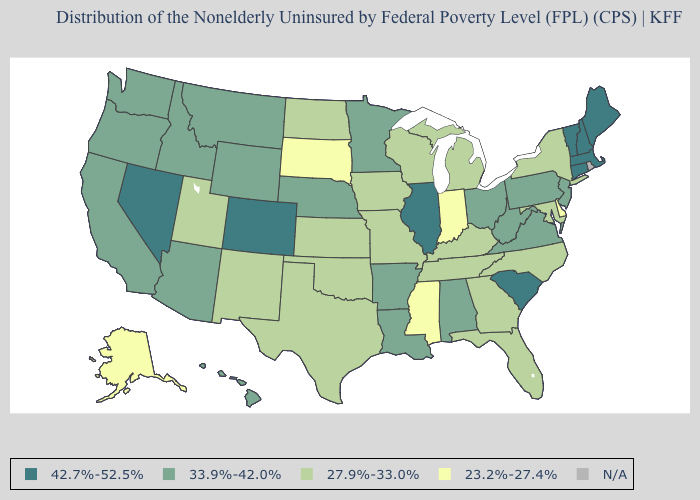Name the states that have a value in the range 42.7%-52.5%?
Quick response, please. Colorado, Connecticut, Illinois, Maine, Massachusetts, Nevada, New Hampshire, South Carolina, Vermont. What is the value of Alaska?
Quick response, please. 23.2%-27.4%. Which states have the highest value in the USA?
Write a very short answer. Colorado, Connecticut, Illinois, Maine, Massachusetts, Nevada, New Hampshire, South Carolina, Vermont. How many symbols are there in the legend?
Be succinct. 5. What is the lowest value in states that border Maine?
Quick response, please. 42.7%-52.5%. Name the states that have a value in the range 42.7%-52.5%?
Concise answer only. Colorado, Connecticut, Illinois, Maine, Massachusetts, Nevada, New Hampshire, South Carolina, Vermont. What is the value of Michigan?
Short answer required. 27.9%-33.0%. What is the value of Arkansas?
Concise answer only. 33.9%-42.0%. How many symbols are there in the legend?
Be succinct. 5. Name the states that have a value in the range 42.7%-52.5%?
Give a very brief answer. Colorado, Connecticut, Illinois, Maine, Massachusetts, Nevada, New Hampshire, South Carolina, Vermont. Which states have the lowest value in the MidWest?
Keep it brief. Indiana, South Dakota. Is the legend a continuous bar?
Answer briefly. No. Among the states that border Indiana , does Illinois have the highest value?
Concise answer only. Yes. Name the states that have a value in the range N/A?
Write a very short answer. Rhode Island. What is the value of New Jersey?
Keep it brief. 33.9%-42.0%. 